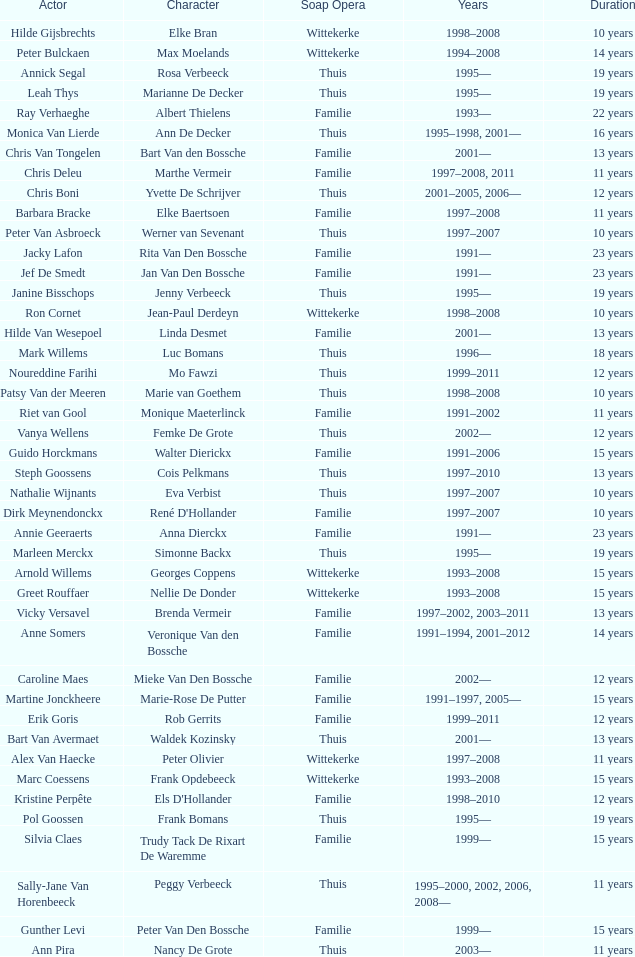What character did Vicky Versavel play for 13 years? Brenda Vermeir. 